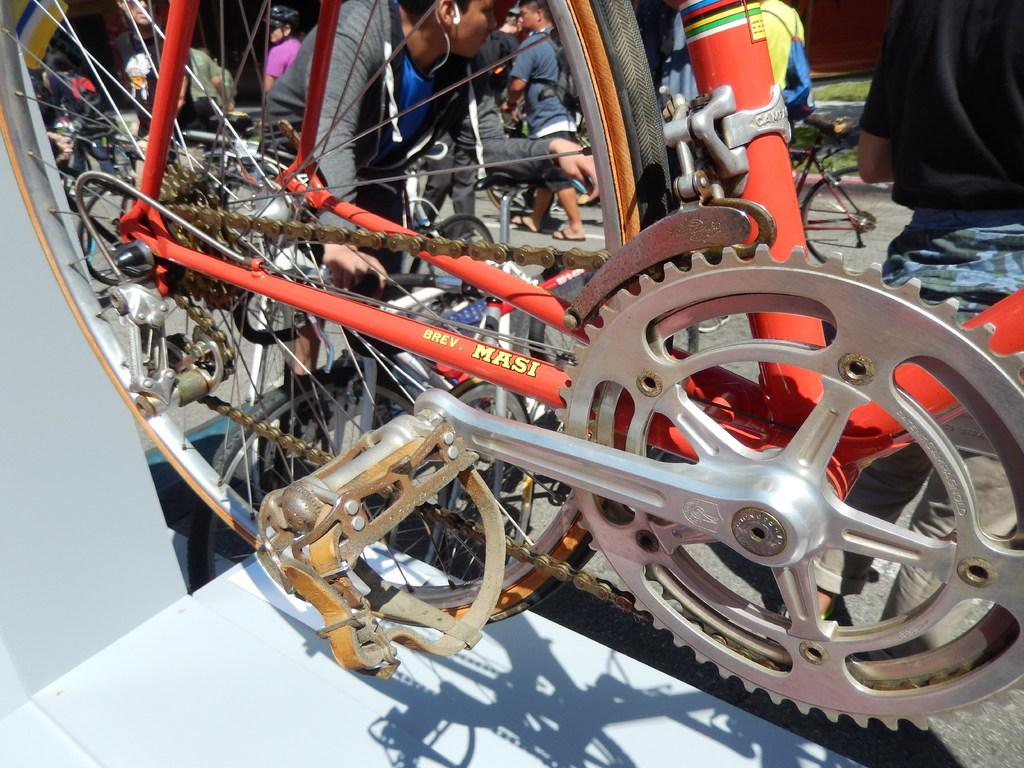What is the main object in the image? There is a cycle in the image. Where is the cycle located? The cycle is on a chair. What color is the chair? The chair is orange in color. Can you describe the people visible behind the cycle? Unfortunately, the facts provided do not give any information about the people visible behind the cycle. What type of cabbage is being stored in the drawer next to the cycle? There is no drawer or cabbage present in the image; it only features a cycle on an orange chair. 